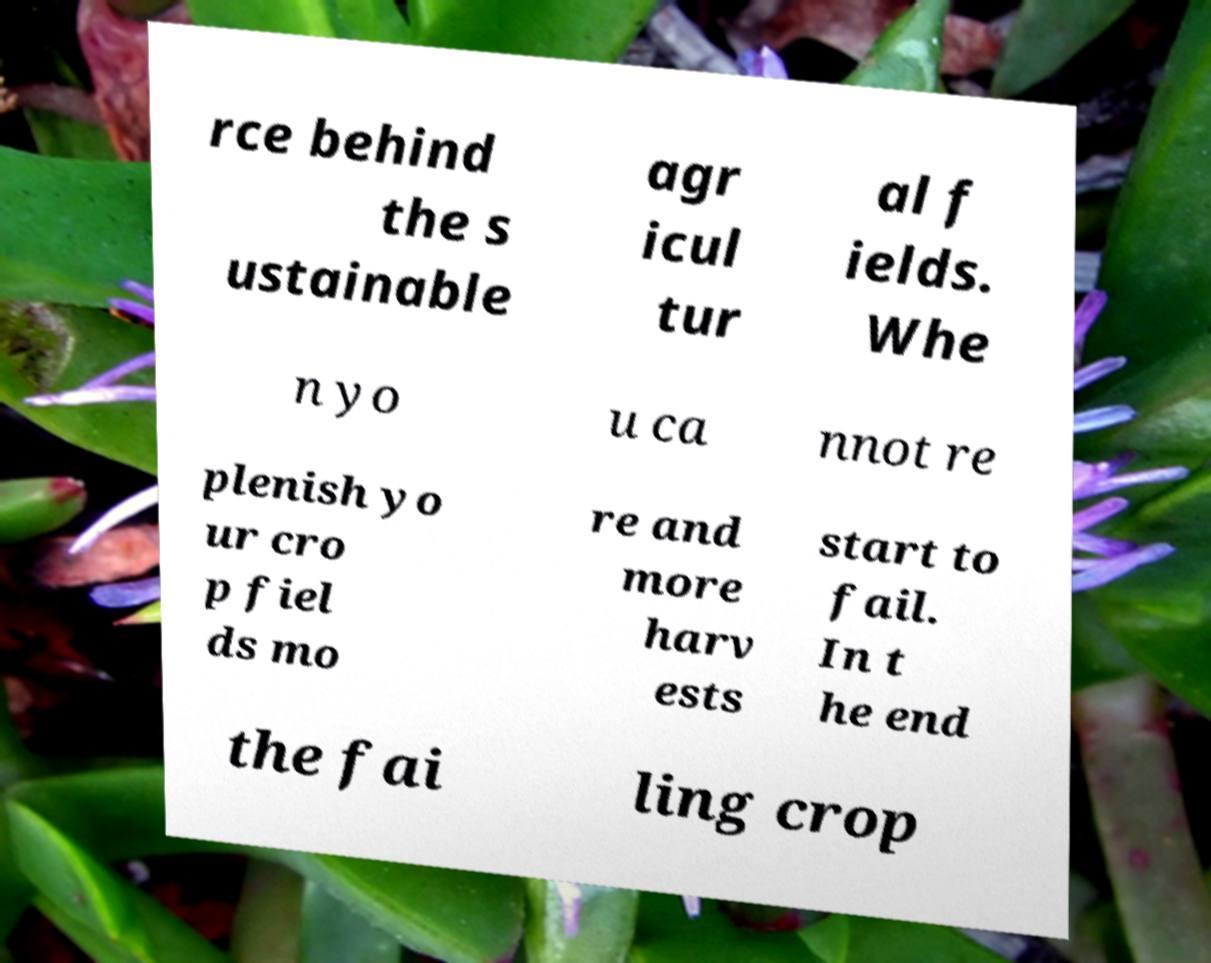Can you accurately transcribe the text from the provided image for me? rce behind the s ustainable agr icul tur al f ields. Whe n yo u ca nnot re plenish yo ur cro p fiel ds mo re and more harv ests start to fail. In t he end the fai ling crop 